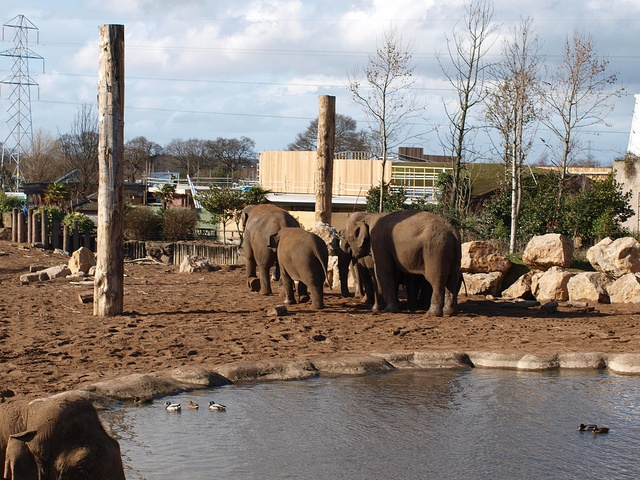Describe the objects in this image and their specific colors. I can see elephant in lightblue, black, gray, and maroon tones, elephant in lightblue, black, gray, brown, and maroon tones, elephant in lightblue, gray, black, brown, and maroon tones, elephant in lightblue, gray, black, brown, and tan tones, and elephant in lightblue, black, gray, and maroon tones in this image. 